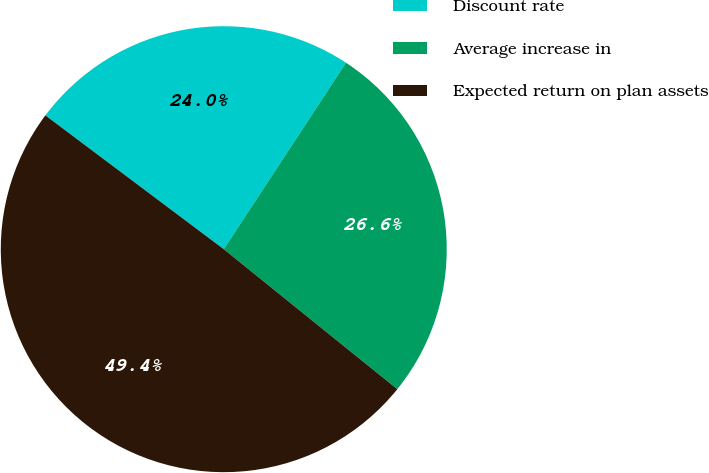Convert chart. <chart><loc_0><loc_0><loc_500><loc_500><pie_chart><fcel>Discount rate<fcel>Average increase in<fcel>Expected return on plan assets<nl><fcel>23.99%<fcel>26.57%<fcel>49.44%<nl></chart> 